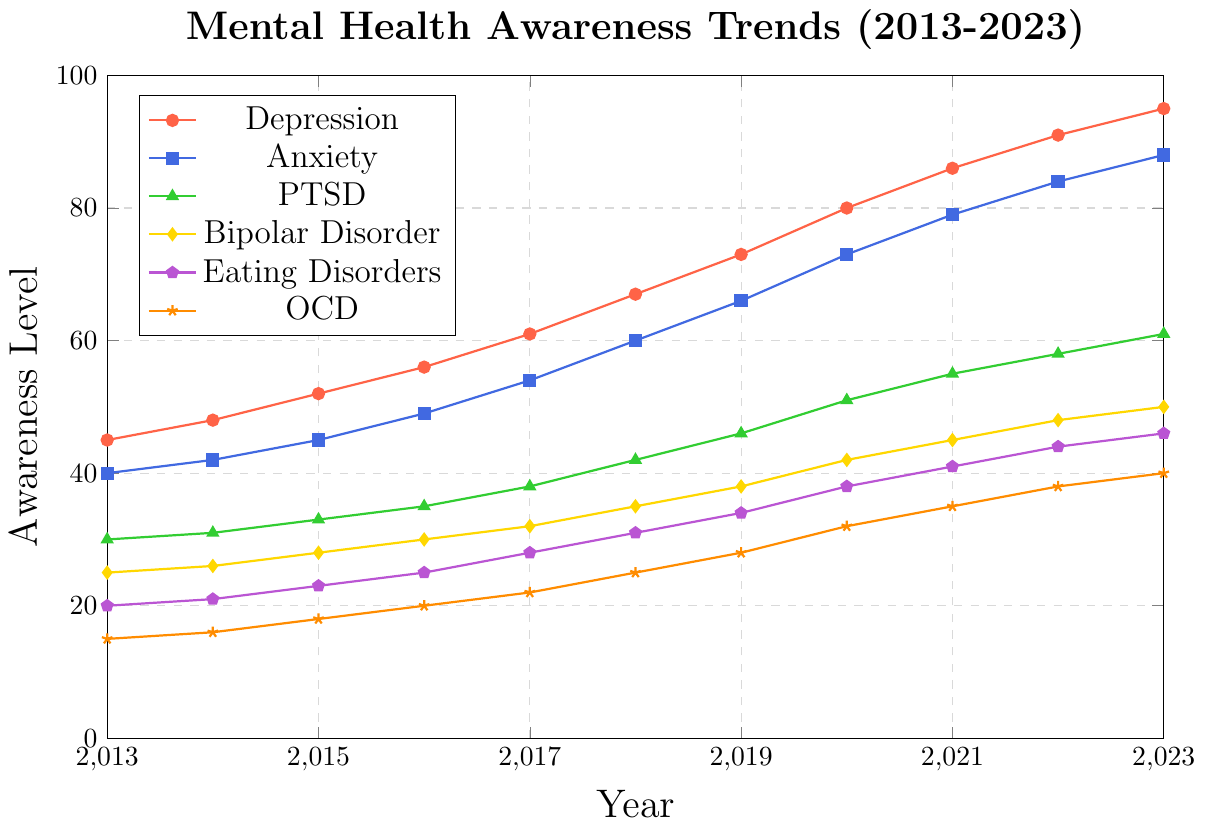What year does bipolar disorder awareness level reach 45? Look at the line representing Bipolar Disorder and find the year where the y-coordinate is 45. This occurs at the point (2021, 45).
Answer: 2021 Which disorder had the lowest awareness level in 2019? Compare the awareness levels for all disorders in the year 2019. The values are: Depression (73), Anxiety (66), PTSD (46), Bipolar Disorder (38), Eating Disorders (34), and OCD (28). OCD has the lowest value.
Answer: OCD What is the difference in awareness levels between Depression and Anxiety in 2023? Find the values for Depression and Anxiety in 2023, which are 95 and 88, respectively. Subtract the Awareness Level of Anxiety from Depression: 95 - 88 = 7.
Answer: 7 By how much did the awareness level for PTSD increase from 2013 to 2023? Find the awareness levels for PTSD in 2013 and 2023, which are 30 and 61 respectively. Subtract the value in 2013 from the value in 2023: 61 - 30 = 31.
Answer: 31 Which disorder showed the most steady increase over the years? Evaluate the slopes of the lines representing each disorder. Depression, Anxiety, PTSD, Bipolar Disorder, Eating Disorders, and OCD show steady increases, but Depression increases the most significantly and steadily.
Answer: Depression What was the average awareness level of Eating Disorders from 2013 to 2023? List awareness levels for Eating Disorders: (20, 21, 23, 25, 28, 31, 34, 38, 41, 44, 46). Sum these values: 20+21+23+25+28+31+34+38+41+44+46 = 351. Divide the sum by the number of years: 351 / 11 = 31.91.
Answer: 31.91 Which year did OCD awareness level surpass 30? Look for the first year that the OCD line passes the y-value of 30. This happens between 2019 and 2020. In 2020, the Awareness Level for OCD is 32.
Answer: 2020 How many disorders had an awareness level over 50 in 2021? Check the awareness levels for all disorders in 2021. The values are: Depression (86), Anxiety (79), PTSD (55), Bipolar Disorder (45), Eating Disorders (41), OCD (35). Depression, Anxiety, and PTSD have values over 50.
Answer: 3 Compare the growth of Anxiety and PTSD awareness levels from 2018 to 2023. Which grew more? Find Awareness levels for Anxiety in 2018 and 2023: (60, 88). Difference: 88 - 60 = 28. For PTSD: (42, 61). Difference: 61 - 42 = 19. Anxiety grew by 28, and PTSD grew by 19. Anxiety grew more.
Answer: Anxiety 